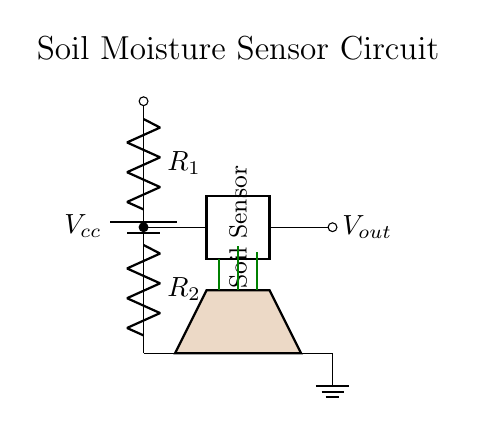What does Vcc represent? Vcc represents the supply voltage for the circuit, which powers the components connected in the diagram.
Answer: supply voltage What are the resistances in the voltage divider? The resistances in this voltage divider are R1 and R2, which are key components that determine the division of voltage.
Answer: R1 and R2 What voltage does the soil sensor output? The output voltage Vout from the voltage divider will vary depending on the resistances and the moisture level detected by the soil sensor, but it is not explicitly stated in the diagram.
Answer: Vout How does soil moisture affect Vout? Soil moisture affects Vout by changing the resistance of the soil sensor, which in turn alters the division of Vcc between R1 and R2, impacting the output voltage.
Answer: changes Vout What happens to Vout if the soil dries? If the soil dries, the resistance of the soil sensor increases, which typically lowers the output voltage Vout due to the voltage divider principle.
Answer: lowers Vout What is the purpose of the battery in this circuit? The purpose of the battery is to provide a constant supply of voltage (Vcc) required to power the voltage divider and the soil sensor.
Answer: power supply 